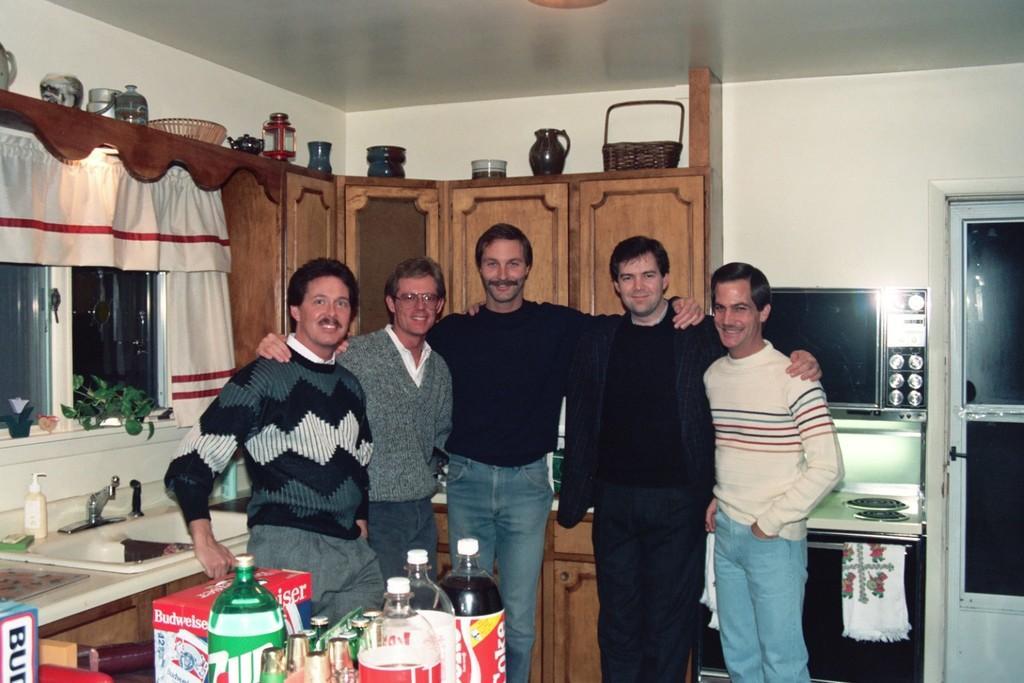Can you describe this image briefly? This Pictures of inside. In the center there are group of men standing and smiling. On the right corner there is a door and a television. In the foreground we can see the table, on the top of which a box and some bottles are placed. In the background we can see the platform, window, curtains and the cabinet on the top of which a basket, jug and some more items are placed. 